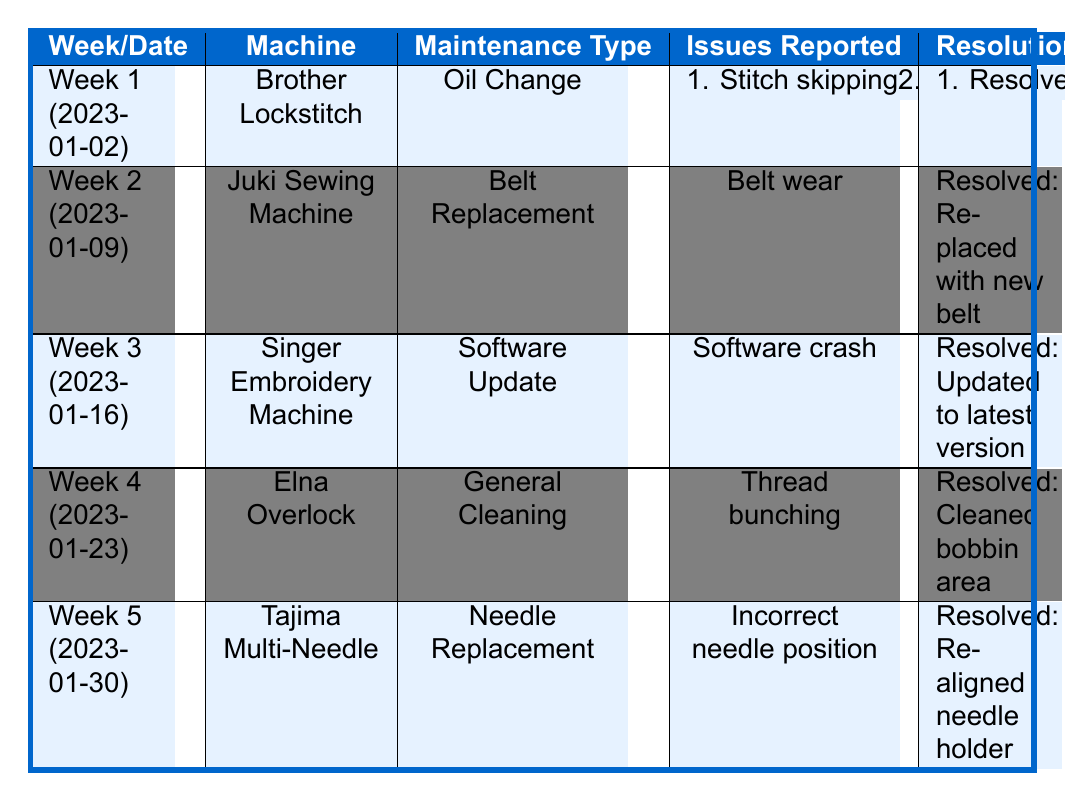What maintenance was performed on the Brother Lockstitch machine? The Brother Lockstitch machine underwent an oil change as indicated in the maintenance type column for Week 1.
Answer: Oil Change Which issue reported for the Juki Sewing Machine was resolved? In Week 2, the only reported issue for the Juki Sewing Machine was "Belt wear," and it was marked as resolved because a new belt was replaced.
Answer: Belt wear How many total issues were reported for the machines in Week 1? In Week 1, there were two issues reported: "Stitch skipping" and "Blade dullness," so the total is 2.
Answer: 2 Did the Tajima Multi-Needle machine have any unresolved issues? The table indicates that all issues reported under the Tajima Multi-Needle machine were resolved, specifically the issue of "Incorrect needle position."
Answer: No What maintenance type was performed the week after the Singer Embroidery Machine maintenance? The week after the Singer Embroidery Machine (Week 3) is Week 4, during which general cleaning was performed on the Elna Overlock machine.
Answer: General Cleaning Which machine had an issue with thread bunching? The Elna Overlock machine had an issue with "Thread bunching," reported in Week 4.
Answer: Elna Overlock Was the issue of "Blade dullness" resolved? The table indicates that the issue of "Blade dullness" reported for the Brother Lockstitch in Week 1 is marked as unresolved, pending replacement.
Answer: No What was the resolution for the software crash reported on the Singer Embroidery Machine? The resolution for the "Software crash" issue was to update the software to the latest version, as indicated in the resolution column for Week 3.
Answer: Updated to latest version Which machine had its maintenance performed before the Juki Sewing Machine? The Brother Lockstitch machine had its maintenance (oil change) performed in Week 1, which is before the Juki Sewing Machine that had its maintenance in Week 2.
Answer: Brother Lockstitch Calculate the total number of resolved issues reported across all weeks. Adding the resolved issues: Week 1 has 1 resolved, Week 2 has 1 resolved, Week 3 has 1 resolved, Week 4 has 1 resolved, Week 5 has 1 resolved, for a total of 5 resolved issues across all weeks.
Answer: 5 